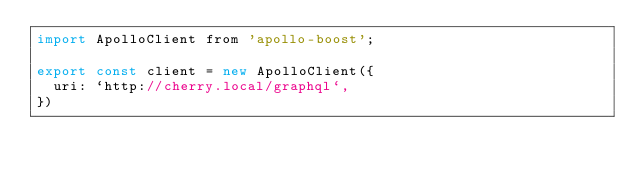Convert code to text. <code><loc_0><loc_0><loc_500><loc_500><_JavaScript_>import ApolloClient from 'apollo-boost';

export const client = new ApolloClient({
  uri: `http://cherry.local/graphql`,
})</code> 